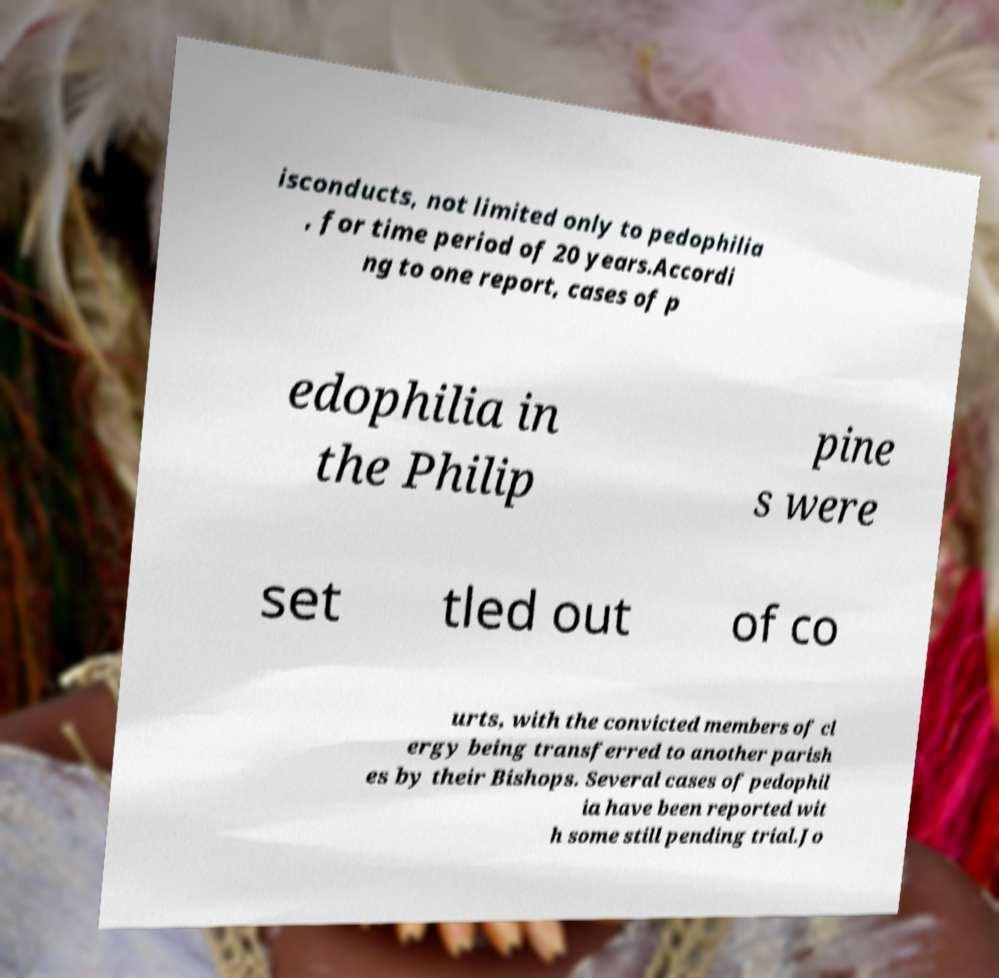I need the written content from this picture converted into text. Can you do that? isconducts, not limited only to pedophilia , for time period of 20 years.Accordi ng to one report, cases of p edophilia in the Philip pine s were set tled out of co urts, with the convicted members of cl ergy being transferred to another parish es by their Bishops. Several cases of pedophil ia have been reported wit h some still pending trial.Jo 